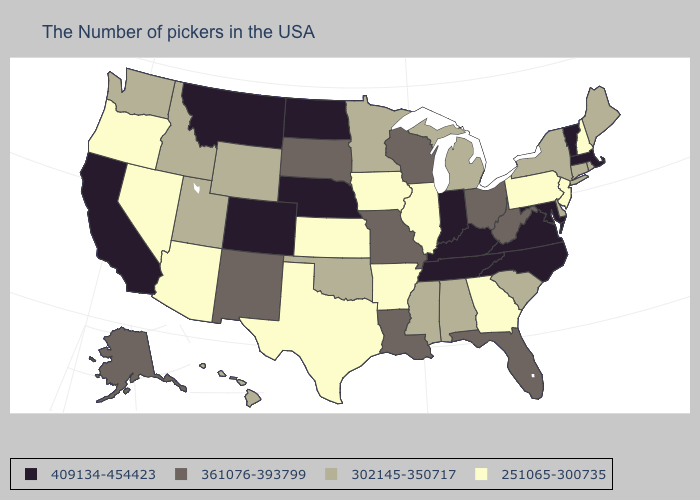Does Ohio have the lowest value in the MidWest?
Be succinct. No. Name the states that have a value in the range 409134-454423?
Short answer required. Massachusetts, Vermont, Maryland, Virginia, North Carolina, Kentucky, Indiana, Tennessee, Nebraska, North Dakota, Colorado, Montana, California. Which states hav the highest value in the MidWest?
Be succinct. Indiana, Nebraska, North Dakota. Does Maine have the lowest value in the Northeast?
Concise answer only. No. What is the value of Missouri?
Give a very brief answer. 361076-393799. Which states have the lowest value in the West?
Answer briefly. Arizona, Nevada, Oregon. Name the states that have a value in the range 409134-454423?
Short answer required. Massachusetts, Vermont, Maryland, Virginia, North Carolina, Kentucky, Indiana, Tennessee, Nebraska, North Dakota, Colorado, Montana, California. Which states have the highest value in the USA?
Concise answer only. Massachusetts, Vermont, Maryland, Virginia, North Carolina, Kentucky, Indiana, Tennessee, Nebraska, North Dakota, Colorado, Montana, California. What is the highest value in the West ?
Concise answer only. 409134-454423. Among the states that border Oklahoma , which have the highest value?
Keep it brief. Colorado. Does the map have missing data?
Concise answer only. No. Name the states that have a value in the range 251065-300735?
Short answer required. New Hampshire, New Jersey, Pennsylvania, Georgia, Illinois, Arkansas, Iowa, Kansas, Texas, Arizona, Nevada, Oregon. Which states have the lowest value in the MidWest?
Be succinct. Illinois, Iowa, Kansas. Does Delaware have a lower value than Idaho?
Be succinct. No. 